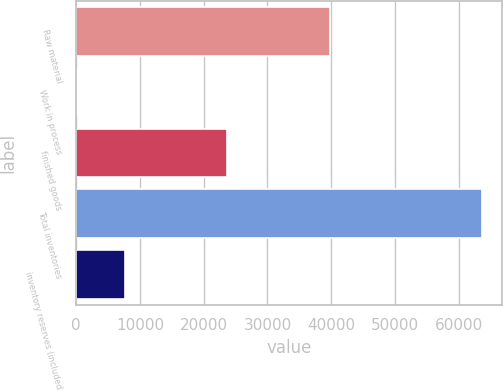Convert chart. <chart><loc_0><loc_0><loc_500><loc_500><bar_chart><fcel>Raw material<fcel>Work in process<fcel>finished goods<fcel>Total inventories<fcel>inventory reserves (included<nl><fcel>39779<fcel>134<fcel>23725<fcel>63638<fcel>7598<nl></chart> 